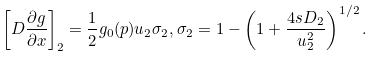Convert formula to latex. <formula><loc_0><loc_0><loc_500><loc_500>\left [ D \frac { \partial g } { \partial x } \right ] _ { 2 } = \frac { 1 } { 2 } g _ { 0 } ( p ) u _ { 2 } \sigma _ { 2 } , \sigma _ { 2 } = 1 - \left ( 1 + \frac { 4 s D _ { 2 } } { u _ { 2 } ^ { 2 } } \right ) ^ { 1 / 2 } .</formula> 